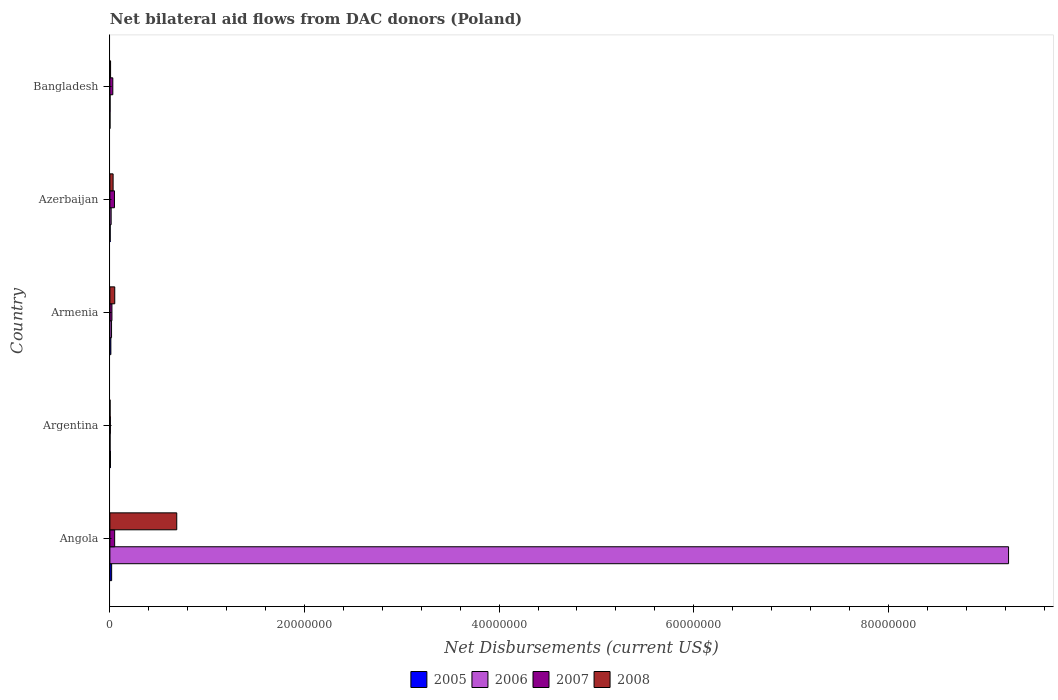How many different coloured bars are there?
Give a very brief answer. 4. How many groups of bars are there?
Offer a terse response. 5. Are the number of bars per tick equal to the number of legend labels?
Provide a short and direct response. Yes. How many bars are there on the 3rd tick from the top?
Your answer should be compact. 4. What is the net bilateral aid flows in 2006 in Azerbaijan?
Your answer should be very brief. 1.30e+05. Across all countries, what is the maximum net bilateral aid flows in 2007?
Provide a short and direct response. 4.90e+05. In which country was the net bilateral aid flows in 2008 maximum?
Keep it short and to the point. Angola. In which country was the net bilateral aid flows in 2007 minimum?
Offer a terse response. Argentina. What is the total net bilateral aid flows in 2007 in the graph?
Your response must be concise. 1.52e+06. What is the difference between the net bilateral aid flows in 2007 in Angola and that in Bangladesh?
Provide a short and direct response. 1.90e+05. What is the average net bilateral aid flows in 2007 per country?
Offer a very short reply. 3.04e+05. What is the ratio of the net bilateral aid flows in 2008 in Armenia to that in Bangladesh?
Provide a short and direct response. 7.14. Is the net bilateral aid flows in 2005 in Azerbaijan less than that in Bangladesh?
Give a very brief answer. No. Is the difference between the net bilateral aid flows in 2007 in Angola and Azerbaijan greater than the difference between the net bilateral aid flows in 2008 in Angola and Azerbaijan?
Your response must be concise. No. What is the difference between the highest and the second highest net bilateral aid flows in 2007?
Your response must be concise. 2.00e+04. What is the difference between the highest and the lowest net bilateral aid flows in 2008?
Your response must be concise. 6.85e+06. In how many countries, is the net bilateral aid flows in 2007 greater than the average net bilateral aid flows in 2007 taken over all countries?
Your answer should be compact. 2. Is the sum of the net bilateral aid flows in 2007 in Azerbaijan and Bangladesh greater than the maximum net bilateral aid flows in 2008 across all countries?
Provide a short and direct response. No. Is it the case that in every country, the sum of the net bilateral aid flows in 2007 and net bilateral aid flows in 2006 is greater than the net bilateral aid flows in 2005?
Your answer should be compact. Yes. What is the difference between two consecutive major ticks on the X-axis?
Your answer should be very brief. 2.00e+07. Are the values on the major ticks of X-axis written in scientific E-notation?
Ensure brevity in your answer.  No. Does the graph contain any zero values?
Give a very brief answer. No. Does the graph contain grids?
Ensure brevity in your answer.  No. Where does the legend appear in the graph?
Your response must be concise. Bottom center. How many legend labels are there?
Make the answer very short. 4. What is the title of the graph?
Your response must be concise. Net bilateral aid flows from DAC donors (Poland). What is the label or title of the X-axis?
Provide a short and direct response. Net Disbursements (current US$). What is the label or title of the Y-axis?
Your answer should be compact. Country. What is the Net Disbursements (current US$) of 2006 in Angola?
Your answer should be very brief. 9.24e+07. What is the Net Disbursements (current US$) in 2008 in Angola?
Offer a very short reply. 6.87e+06. What is the Net Disbursements (current US$) in 2006 in Argentina?
Make the answer very short. 2.00e+04. What is the Net Disbursements (current US$) in 2005 in Armenia?
Your answer should be very brief. 1.00e+05. What is the Net Disbursements (current US$) in 2008 in Armenia?
Provide a succinct answer. 5.00e+05. What is the Net Disbursements (current US$) in 2007 in Azerbaijan?
Your response must be concise. 4.70e+05. What is the Net Disbursements (current US$) of 2005 in Bangladesh?
Your answer should be compact. 10000. What is the Net Disbursements (current US$) in 2008 in Bangladesh?
Give a very brief answer. 7.00e+04. Across all countries, what is the maximum Net Disbursements (current US$) of 2005?
Give a very brief answer. 1.80e+05. Across all countries, what is the maximum Net Disbursements (current US$) of 2006?
Offer a very short reply. 9.24e+07. Across all countries, what is the maximum Net Disbursements (current US$) in 2008?
Your response must be concise. 6.87e+06. Across all countries, what is the minimum Net Disbursements (current US$) of 2005?
Offer a very short reply. 10000. Across all countries, what is the minimum Net Disbursements (current US$) of 2008?
Your response must be concise. 2.00e+04. What is the total Net Disbursements (current US$) of 2005 in the graph?
Keep it short and to the point. 3.80e+05. What is the total Net Disbursements (current US$) in 2006 in the graph?
Your answer should be very brief. 9.27e+07. What is the total Net Disbursements (current US$) of 2007 in the graph?
Offer a terse response. 1.52e+06. What is the total Net Disbursements (current US$) of 2008 in the graph?
Offer a terse response. 7.79e+06. What is the difference between the Net Disbursements (current US$) of 2005 in Angola and that in Argentina?
Your answer should be very brief. 1.20e+05. What is the difference between the Net Disbursements (current US$) in 2006 in Angola and that in Argentina?
Keep it short and to the point. 9.23e+07. What is the difference between the Net Disbursements (current US$) of 2008 in Angola and that in Argentina?
Provide a succinct answer. 6.85e+06. What is the difference between the Net Disbursements (current US$) of 2006 in Angola and that in Armenia?
Provide a short and direct response. 9.22e+07. What is the difference between the Net Disbursements (current US$) in 2007 in Angola and that in Armenia?
Keep it short and to the point. 2.80e+05. What is the difference between the Net Disbursements (current US$) of 2008 in Angola and that in Armenia?
Your response must be concise. 6.37e+06. What is the difference between the Net Disbursements (current US$) in 2006 in Angola and that in Azerbaijan?
Make the answer very short. 9.22e+07. What is the difference between the Net Disbursements (current US$) of 2007 in Angola and that in Azerbaijan?
Offer a terse response. 2.00e+04. What is the difference between the Net Disbursements (current US$) of 2008 in Angola and that in Azerbaijan?
Make the answer very short. 6.54e+06. What is the difference between the Net Disbursements (current US$) of 2006 in Angola and that in Bangladesh?
Your response must be concise. 9.23e+07. What is the difference between the Net Disbursements (current US$) of 2007 in Angola and that in Bangladesh?
Offer a terse response. 1.90e+05. What is the difference between the Net Disbursements (current US$) in 2008 in Angola and that in Bangladesh?
Make the answer very short. 6.80e+06. What is the difference between the Net Disbursements (current US$) of 2005 in Argentina and that in Armenia?
Give a very brief answer. -4.00e+04. What is the difference between the Net Disbursements (current US$) in 2006 in Argentina and that in Armenia?
Offer a terse response. -1.50e+05. What is the difference between the Net Disbursements (current US$) of 2008 in Argentina and that in Armenia?
Offer a terse response. -4.80e+05. What is the difference between the Net Disbursements (current US$) in 2007 in Argentina and that in Azerbaijan?
Ensure brevity in your answer.  -4.20e+05. What is the difference between the Net Disbursements (current US$) in 2008 in Argentina and that in Azerbaijan?
Offer a terse response. -3.10e+05. What is the difference between the Net Disbursements (current US$) of 2007 in Argentina and that in Bangladesh?
Keep it short and to the point. -2.50e+05. What is the difference between the Net Disbursements (current US$) in 2007 in Armenia and that in Bangladesh?
Give a very brief answer. -9.00e+04. What is the difference between the Net Disbursements (current US$) in 2005 in Azerbaijan and that in Bangladesh?
Keep it short and to the point. 2.00e+04. What is the difference between the Net Disbursements (current US$) in 2007 in Azerbaijan and that in Bangladesh?
Your answer should be compact. 1.70e+05. What is the difference between the Net Disbursements (current US$) in 2008 in Azerbaijan and that in Bangladesh?
Your answer should be very brief. 2.60e+05. What is the difference between the Net Disbursements (current US$) of 2005 in Angola and the Net Disbursements (current US$) of 2006 in Argentina?
Provide a succinct answer. 1.60e+05. What is the difference between the Net Disbursements (current US$) in 2005 in Angola and the Net Disbursements (current US$) in 2007 in Argentina?
Provide a succinct answer. 1.30e+05. What is the difference between the Net Disbursements (current US$) of 2005 in Angola and the Net Disbursements (current US$) of 2008 in Argentina?
Give a very brief answer. 1.60e+05. What is the difference between the Net Disbursements (current US$) in 2006 in Angola and the Net Disbursements (current US$) in 2007 in Argentina?
Provide a short and direct response. 9.23e+07. What is the difference between the Net Disbursements (current US$) of 2006 in Angola and the Net Disbursements (current US$) of 2008 in Argentina?
Provide a succinct answer. 9.23e+07. What is the difference between the Net Disbursements (current US$) in 2007 in Angola and the Net Disbursements (current US$) in 2008 in Argentina?
Make the answer very short. 4.70e+05. What is the difference between the Net Disbursements (current US$) in 2005 in Angola and the Net Disbursements (current US$) in 2006 in Armenia?
Provide a short and direct response. 10000. What is the difference between the Net Disbursements (current US$) in 2005 in Angola and the Net Disbursements (current US$) in 2008 in Armenia?
Give a very brief answer. -3.20e+05. What is the difference between the Net Disbursements (current US$) in 2006 in Angola and the Net Disbursements (current US$) in 2007 in Armenia?
Provide a short and direct response. 9.21e+07. What is the difference between the Net Disbursements (current US$) in 2006 in Angola and the Net Disbursements (current US$) in 2008 in Armenia?
Offer a very short reply. 9.18e+07. What is the difference between the Net Disbursements (current US$) of 2007 in Angola and the Net Disbursements (current US$) of 2008 in Armenia?
Offer a very short reply. -10000. What is the difference between the Net Disbursements (current US$) of 2005 in Angola and the Net Disbursements (current US$) of 2007 in Azerbaijan?
Your answer should be very brief. -2.90e+05. What is the difference between the Net Disbursements (current US$) in 2006 in Angola and the Net Disbursements (current US$) in 2007 in Azerbaijan?
Offer a very short reply. 9.19e+07. What is the difference between the Net Disbursements (current US$) in 2006 in Angola and the Net Disbursements (current US$) in 2008 in Azerbaijan?
Provide a succinct answer. 9.20e+07. What is the difference between the Net Disbursements (current US$) in 2007 in Angola and the Net Disbursements (current US$) in 2008 in Azerbaijan?
Ensure brevity in your answer.  1.60e+05. What is the difference between the Net Disbursements (current US$) of 2005 in Angola and the Net Disbursements (current US$) of 2007 in Bangladesh?
Keep it short and to the point. -1.20e+05. What is the difference between the Net Disbursements (current US$) of 2006 in Angola and the Net Disbursements (current US$) of 2007 in Bangladesh?
Ensure brevity in your answer.  9.20e+07. What is the difference between the Net Disbursements (current US$) of 2006 in Angola and the Net Disbursements (current US$) of 2008 in Bangladesh?
Your answer should be very brief. 9.23e+07. What is the difference between the Net Disbursements (current US$) in 2005 in Argentina and the Net Disbursements (current US$) in 2006 in Armenia?
Make the answer very short. -1.10e+05. What is the difference between the Net Disbursements (current US$) of 2005 in Argentina and the Net Disbursements (current US$) of 2007 in Armenia?
Provide a succinct answer. -1.50e+05. What is the difference between the Net Disbursements (current US$) of 2005 in Argentina and the Net Disbursements (current US$) of 2008 in Armenia?
Offer a terse response. -4.40e+05. What is the difference between the Net Disbursements (current US$) of 2006 in Argentina and the Net Disbursements (current US$) of 2007 in Armenia?
Offer a terse response. -1.90e+05. What is the difference between the Net Disbursements (current US$) of 2006 in Argentina and the Net Disbursements (current US$) of 2008 in Armenia?
Ensure brevity in your answer.  -4.80e+05. What is the difference between the Net Disbursements (current US$) of 2007 in Argentina and the Net Disbursements (current US$) of 2008 in Armenia?
Offer a very short reply. -4.50e+05. What is the difference between the Net Disbursements (current US$) in 2005 in Argentina and the Net Disbursements (current US$) in 2006 in Azerbaijan?
Offer a very short reply. -7.00e+04. What is the difference between the Net Disbursements (current US$) of 2005 in Argentina and the Net Disbursements (current US$) of 2007 in Azerbaijan?
Provide a short and direct response. -4.10e+05. What is the difference between the Net Disbursements (current US$) of 2005 in Argentina and the Net Disbursements (current US$) of 2008 in Azerbaijan?
Your answer should be compact. -2.70e+05. What is the difference between the Net Disbursements (current US$) in 2006 in Argentina and the Net Disbursements (current US$) in 2007 in Azerbaijan?
Offer a very short reply. -4.50e+05. What is the difference between the Net Disbursements (current US$) of 2006 in Argentina and the Net Disbursements (current US$) of 2008 in Azerbaijan?
Give a very brief answer. -3.10e+05. What is the difference between the Net Disbursements (current US$) of 2007 in Argentina and the Net Disbursements (current US$) of 2008 in Azerbaijan?
Your answer should be compact. -2.80e+05. What is the difference between the Net Disbursements (current US$) of 2005 in Argentina and the Net Disbursements (current US$) of 2006 in Bangladesh?
Your response must be concise. 4.00e+04. What is the difference between the Net Disbursements (current US$) of 2006 in Argentina and the Net Disbursements (current US$) of 2007 in Bangladesh?
Your answer should be compact. -2.80e+05. What is the difference between the Net Disbursements (current US$) in 2007 in Argentina and the Net Disbursements (current US$) in 2008 in Bangladesh?
Your answer should be very brief. -2.00e+04. What is the difference between the Net Disbursements (current US$) in 2005 in Armenia and the Net Disbursements (current US$) in 2007 in Azerbaijan?
Your answer should be very brief. -3.70e+05. What is the difference between the Net Disbursements (current US$) in 2006 in Armenia and the Net Disbursements (current US$) in 2008 in Azerbaijan?
Provide a succinct answer. -1.60e+05. What is the difference between the Net Disbursements (current US$) in 2005 in Armenia and the Net Disbursements (current US$) in 2007 in Bangladesh?
Your answer should be very brief. -2.00e+05. What is the difference between the Net Disbursements (current US$) in 2005 in Armenia and the Net Disbursements (current US$) in 2008 in Bangladesh?
Make the answer very short. 3.00e+04. What is the difference between the Net Disbursements (current US$) in 2006 in Armenia and the Net Disbursements (current US$) in 2007 in Bangladesh?
Offer a terse response. -1.30e+05. What is the difference between the Net Disbursements (current US$) in 2006 in Armenia and the Net Disbursements (current US$) in 2008 in Bangladesh?
Provide a short and direct response. 1.00e+05. What is the difference between the Net Disbursements (current US$) in 2006 in Azerbaijan and the Net Disbursements (current US$) in 2008 in Bangladesh?
Give a very brief answer. 6.00e+04. What is the difference between the Net Disbursements (current US$) of 2007 in Azerbaijan and the Net Disbursements (current US$) of 2008 in Bangladesh?
Make the answer very short. 4.00e+05. What is the average Net Disbursements (current US$) of 2005 per country?
Provide a short and direct response. 7.60e+04. What is the average Net Disbursements (current US$) in 2006 per country?
Ensure brevity in your answer.  1.85e+07. What is the average Net Disbursements (current US$) in 2007 per country?
Offer a terse response. 3.04e+05. What is the average Net Disbursements (current US$) in 2008 per country?
Your answer should be very brief. 1.56e+06. What is the difference between the Net Disbursements (current US$) of 2005 and Net Disbursements (current US$) of 2006 in Angola?
Make the answer very short. -9.22e+07. What is the difference between the Net Disbursements (current US$) of 2005 and Net Disbursements (current US$) of 2007 in Angola?
Offer a terse response. -3.10e+05. What is the difference between the Net Disbursements (current US$) in 2005 and Net Disbursements (current US$) in 2008 in Angola?
Your response must be concise. -6.69e+06. What is the difference between the Net Disbursements (current US$) of 2006 and Net Disbursements (current US$) of 2007 in Angola?
Ensure brevity in your answer.  9.19e+07. What is the difference between the Net Disbursements (current US$) in 2006 and Net Disbursements (current US$) in 2008 in Angola?
Offer a terse response. 8.55e+07. What is the difference between the Net Disbursements (current US$) of 2007 and Net Disbursements (current US$) of 2008 in Angola?
Offer a very short reply. -6.38e+06. What is the difference between the Net Disbursements (current US$) in 2005 and Net Disbursements (current US$) in 2007 in Argentina?
Keep it short and to the point. 10000. What is the difference between the Net Disbursements (current US$) of 2005 and Net Disbursements (current US$) of 2008 in Argentina?
Ensure brevity in your answer.  4.00e+04. What is the difference between the Net Disbursements (current US$) of 2006 and Net Disbursements (current US$) of 2007 in Argentina?
Make the answer very short. -3.00e+04. What is the difference between the Net Disbursements (current US$) of 2006 and Net Disbursements (current US$) of 2008 in Argentina?
Offer a very short reply. 0. What is the difference between the Net Disbursements (current US$) of 2007 and Net Disbursements (current US$) of 2008 in Argentina?
Provide a short and direct response. 3.00e+04. What is the difference between the Net Disbursements (current US$) in 2005 and Net Disbursements (current US$) in 2007 in Armenia?
Offer a very short reply. -1.10e+05. What is the difference between the Net Disbursements (current US$) of 2005 and Net Disbursements (current US$) of 2008 in Armenia?
Provide a short and direct response. -4.00e+05. What is the difference between the Net Disbursements (current US$) of 2006 and Net Disbursements (current US$) of 2007 in Armenia?
Your answer should be very brief. -4.00e+04. What is the difference between the Net Disbursements (current US$) in 2006 and Net Disbursements (current US$) in 2008 in Armenia?
Make the answer very short. -3.30e+05. What is the difference between the Net Disbursements (current US$) in 2007 and Net Disbursements (current US$) in 2008 in Armenia?
Your answer should be very brief. -2.90e+05. What is the difference between the Net Disbursements (current US$) in 2005 and Net Disbursements (current US$) in 2006 in Azerbaijan?
Offer a very short reply. -1.00e+05. What is the difference between the Net Disbursements (current US$) in 2005 and Net Disbursements (current US$) in 2007 in Azerbaijan?
Ensure brevity in your answer.  -4.40e+05. What is the difference between the Net Disbursements (current US$) of 2006 and Net Disbursements (current US$) of 2007 in Azerbaijan?
Ensure brevity in your answer.  -3.40e+05. What is the difference between the Net Disbursements (current US$) of 2007 and Net Disbursements (current US$) of 2008 in Azerbaijan?
Offer a terse response. 1.40e+05. What is the difference between the Net Disbursements (current US$) of 2005 and Net Disbursements (current US$) of 2006 in Bangladesh?
Give a very brief answer. -10000. What is the difference between the Net Disbursements (current US$) of 2005 and Net Disbursements (current US$) of 2008 in Bangladesh?
Your answer should be compact. -6.00e+04. What is the difference between the Net Disbursements (current US$) in 2006 and Net Disbursements (current US$) in 2007 in Bangladesh?
Your response must be concise. -2.80e+05. What is the difference between the Net Disbursements (current US$) in 2007 and Net Disbursements (current US$) in 2008 in Bangladesh?
Offer a very short reply. 2.30e+05. What is the ratio of the Net Disbursements (current US$) of 2006 in Angola to that in Argentina?
Keep it short and to the point. 4617.5. What is the ratio of the Net Disbursements (current US$) of 2007 in Angola to that in Argentina?
Offer a very short reply. 9.8. What is the ratio of the Net Disbursements (current US$) of 2008 in Angola to that in Argentina?
Provide a succinct answer. 343.5. What is the ratio of the Net Disbursements (current US$) of 2005 in Angola to that in Armenia?
Keep it short and to the point. 1.8. What is the ratio of the Net Disbursements (current US$) of 2006 in Angola to that in Armenia?
Give a very brief answer. 543.24. What is the ratio of the Net Disbursements (current US$) in 2007 in Angola to that in Armenia?
Your answer should be very brief. 2.33. What is the ratio of the Net Disbursements (current US$) in 2008 in Angola to that in Armenia?
Your answer should be compact. 13.74. What is the ratio of the Net Disbursements (current US$) of 2006 in Angola to that in Azerbaijan?
Make the answer very short. 710.38. What is the ratio of the Net Disbursements (current US$) of 2007 in Angola to that in Azerbaijan?
Your answer should be compact. 1.04. What is the ratio of the Net Disbursements (current US$) of 2008 in Angola to that in Azerbaijan?
Your answer should be compact. 20.82. What is the ratio of the Net Disbursements (current US$) of 2006 in Angola to that in Bangladesh?
Keep it short and to the point. 4617.5. What is the ratio of the Net Disbursements (current US$) in 2007 in Angola to that in Bangladesh?
Provide a short and direct response. 1.63. What is the ratio of the Net Disbursements (current US$) in 2008 in Angola to that in Bangladesh?
Make the answer very short. 98.14. What is the ratio of the Net Disbursements (current US$) of 2005 in Argentina to that in Armenia?
Give a very brief answer. 0.6. What is the ratio of the Net Disbursements (current US$) of 2006 in Argentina to that in Armenia?
Provide a succinct answer. 0.12. What is the ratio of the Net Disbursements (current US$) of 2007 in Argentina to that in Armenia?
Your answer should be compact. 0.24. What is the ratio of the Net Disbursements (current US$) of 2008 in Argentina to that in Armenia?
Your answer should be very brief. 0.04. What is the ratio of the Net Disbursements (current US$) in 2006 in Argentina to that in Azerbaijan?
Make the answer very short. 0.15. What is the ratio of the Net Disbursements (current US$) in 2007 in Argentina to that in Azerbaijan?
Keep it short and to the point. 0.11. What is the ratio of the Net Disbursements (current US$) of 2008 in Argentina to that in Azerbaijan?
Give a very brief answer. 0.06. What is the ratio of the Net Disbursements (current US$) of 2006 in Argentina to that in Bangladesh?
Make the answer very short. 1. What is the ratio of the Net Disbursements (current US$) in 2007 in Argentina to that in Bangladesh?
Your answer should be very brief. 0.17. What is the ratio of the Net Disbursements (current US$) in 2008 in Argentina to that in Bangladesh?
Your answer should be compact. 0.29. What is the ratio of the Net Disbursements (current US$) in 2006 in Armenia to that in Azerbaijan?
Your answer should be very brief. 1.31. What is the ratio of the Net Disbursements (current US$) in 2007 in Armenia to that in Azerbaijan?
Your answer should be very brief. 0.45. What is the ratio of the Net Disbursements (current US$) in 2008 in Armenia to that in Azerbaijan?
Offer a very short reply. 1.52. What is the ratio of the Net Disbursements (current US$) of 2005 in Armenia to that in Bangladesh?
Provide a succinct answer. 10. What is the ratio of the Net Disbursements (current US$) of 2006 in Armenia to that in Bangladesh?
Offer a terse response. 8.5. What is the ratio of the Net Disbursements (current US$) in 2007 in Armenia to that in Bangladesh?
Keep it short and to the point. 0.7. What is the ratio of the Net Disbursements (current US$) in 2008 in Armenia to that in Bangladesh?
Keep it short and to the point. 7.14. What is the ratio of the Net Disbursements (current US$) in 2006 in Azerbaijan to that in Bangladesh?
Your answer should be compact. 6.5. What is the ratio of the Net Disbursements (current US$) in 2007 in Azerbaijan to that in Bangladesh?
Keep it short and to the point. 1.57. What is the ratio of the Net Disbursements (current US$) of 2008 in Azerbaijan to that in Bangladesh?
Provide a succinct answer. 4.71. What is the difference between the highest and the second highest Net Disbursements (current US$) of 2006?
Give a very brief answer. 9.22e+07. What is the difference between the highest and the second highest Net Disbursements (current US$) in 2007?
Make the answer very short. 2.00e+04. What is the difference between the highest and the second highest Net Disbursements (current US$) of 2008?
Ensure brevity in your answer.  6.37e+06. What is the difference between the highest and the lowest Net Disbursements (current US$) of 2006?
Provide a short and direct response. 9.23e+07. What is the difference between the highest and the lowest Net Disbursements (current US$) in 2008?
Ensure brevity in your answer.  6.85e+06. 